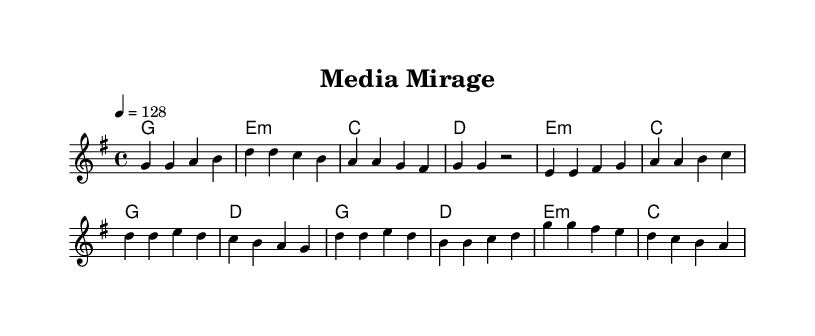What is the key signature of this music? The key signature is G major, which has one sharp (F#).
Answer: G major What is the time signature of this music? The time signature is 4/4, indicating four beats per measure.
Answer: 4/4 What is the tempo marking for this piece? The tempo marking is a quarter note equals 128 beats per minute.
Answer: 128 How many phrases are there in the chorus section? The chorus section consists of four distinct phrases based on the melodic structure.
Answer: Four What is the lyrical theme of this K-Pop track? The lyrical theme critiques media influence and promotes independent thinking, focusing on how narratives are controlled.
Answer: Media influence Which section contains the lyrics "Break free from the media mirage"? This line is found in the chorus, which conveys a central message of resisting media manipulation.
Answer: Chorus How does the harmony change in the pre-chorus compared to the verse? The pre-chorus introduces minor harmonies, contrasting the major harmonies of the verse, adding emotional tension.
Answer: Minor harmonies 